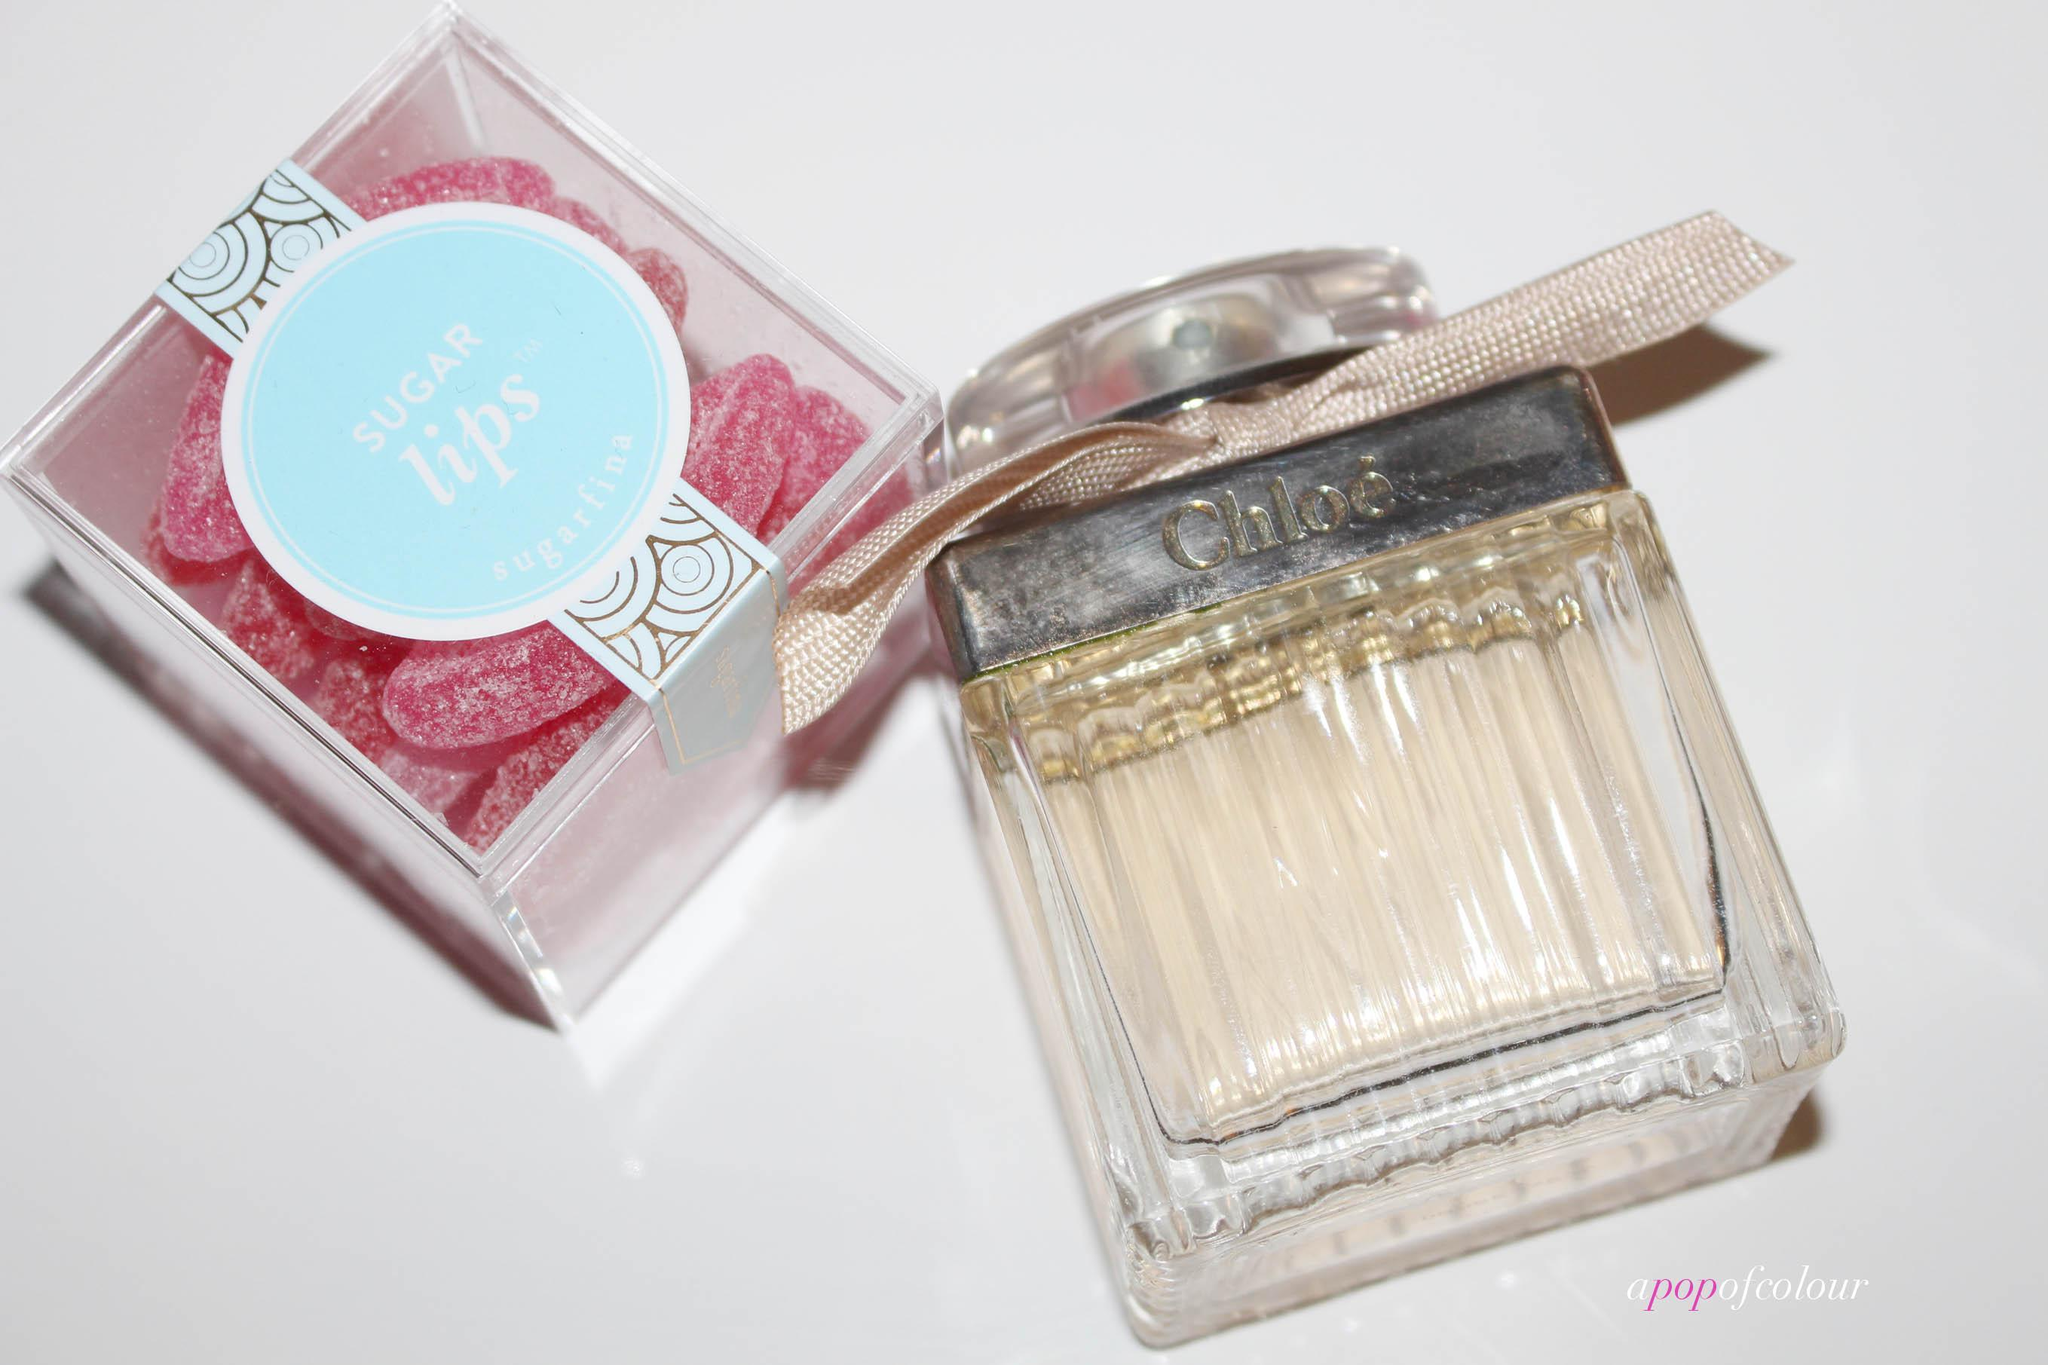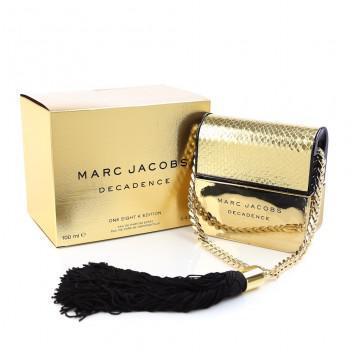The first image is the image on the left, the second image is the image on the right. Assess this claim about the two images: "A golden bottle of perfume with a golden chain and black tassel is sitting next to a matching golden box.". Correct or not? Answer yes or no. Yes. The first image is the image on the left, the second image is the image on the right. Given the left and right images, does the statement "there is a perfume container with a chain and tassles" hold true? Answer yes or no. Yes. 